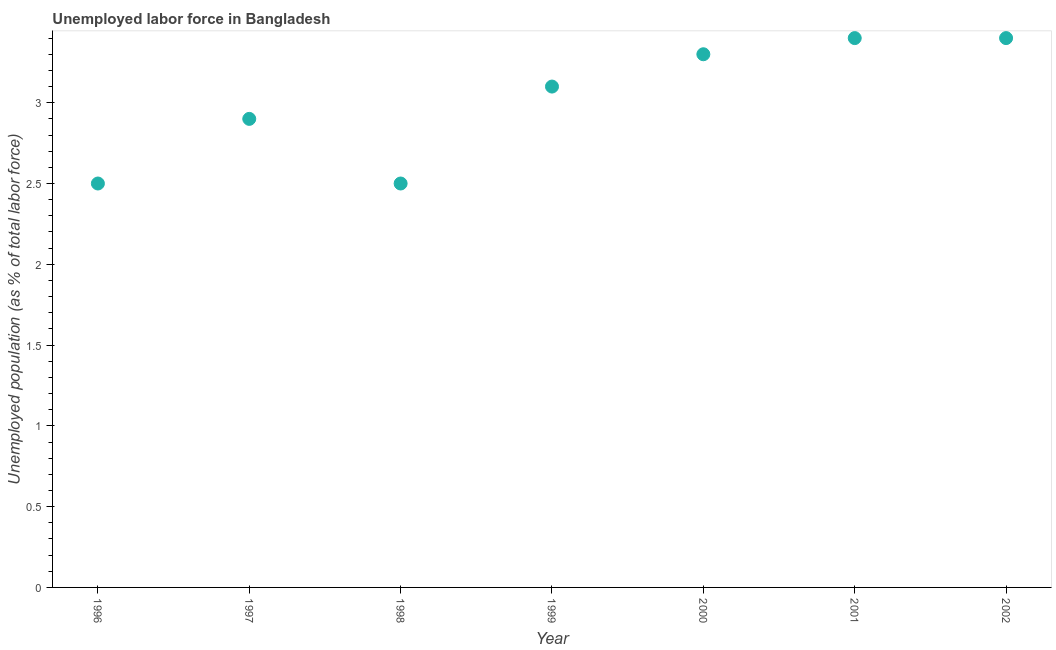What is the total unemployed population in 1999?
Make the answer very short. 3.1. Across all years, what is the maximum total unemployed population?
Your response must be concise. 3.4. Across all years, what is the minimum total unemployed population?
Your answer should be very brief. 2.5. What is the sum of the total unemployed population?
Provide a short and direct response. 21.1. What is the difference between the total unemployed population in 1997 and 2000?
Your answer should be very brief. -0.4. What is the average total unemployed population per year?
Keep it short and to the point. 3.01. What is the median total unemployed population?
Make the answer very short. 3.1. Do a majority of the years between 1996 and 2002 (inclusive) have total unemployed population greater than 3.2 %?
Offer a very short reply. No. What is the ratio of the total unemployed population in 1997 to that in 2000?
Offer a very short reply. 0.88. Is the total unemployed population in 2001 less than that in 2002?
Your answer should be very brief. No. What is the difference between the highest and the second highest total unemployed population?
Make the answer very short. 0. What is the difference between the highest and the lowest total unemployed population?
Make the answer very short. 0.9. In how many years, is the total unemployed population greater than the average total unemployed population taken over all years?
Provide a succinct answer. 4. Does the total unemployed population monotonically increase over the years?
Offer a very short reply. No. How many years are there in the graph?
Your response must be concise. 7. What is the difference between two consecutive major ticks on the Y-axis?
Keep it short and to the point. 0.5. Does the graph contain grids?
Offer a terse response. No. What is the title of the graph?
Make the answer very short. Unemployed labor force in Bangladesh. What is the label or title of the X-axis?
Your response must be concise. Year. What is the label or title of the Y-axis?
Make the answer very short. Unemployed population (as % of total labor force). What is the Unemployed population (as % of total labor force) in 1996?
Ensure brevity in your answer.  2.5. What is the Unemployed population (as % of total labor force) in 1997?
Give a very brief answer. 2.9. What is the Unemployed population (as % of total labor force) in 1999?
Your answer should be very brief. 3.1. What is the Unemployed population (as % of total labor force) in 2000?
Give a very brief answer. 3.3. What is the Unemployed population (as % of total labor force) in 2001?
Make the answer very short. 3.4. What is the Unemployed population (as % of total labor force) in 2002?
Offer a very short reply. 3.4. What is the difference between the Unemployed population (as % of total labor force) in 1997 and 1998?
Offer a terse response. 0.4. What is the difference between the Unemployed population (as % of total labor force) in 1997 and 1999?
Offer a very short reply. -0.2. What is the difference between the Unemployed population (as % of total labor force) in 1997 and 2001?
Give a very brief answer. -0.5. What is the difference between the Unemployed population (as % of total labor force) in 1998 and 1999?
Keep it short and to the point. -0.6. What is the difference between the Unemployed population (as % of total labor force) in 1998 and 2001?
Make the answer very short. -0.9. What is the difference between the Unemployed population (as % of total labor force) in 1999 and 2002?
Provide a succinct answer. -0.3. What is the difference between the Unemployed population (as % of total labor force) in 2000 and 2001?
Keep it short and to the point. -0.1. What is the difference between the Unemployed population (as % of total labor force) in 2000 and 2002?
Your answer should be very brief. -0.1. What is the ratio of the Unemployed population (as % of total labor force) in 1996 to that in 1997?
Ensure brevity in your answer.  0.86. What is the ratio of the Unemployed population (as % of total labor force) in 1996 to that in 1998?
Your answer should be compact. 1. What is the ratio of the Unemployed population (as % of total labor force) in 1996 to that in 1999?
Offer a terse response. 0.81. What is the ratio of the Unemployed population (as % of total labor force) in 1996 to that in 2000?
Give a very brief answer. 0.76. What is the ratio of the Unemployed population (as % of total labor force) in 1996 to that in 2001?
Give a very brief answer. 0.73. What is the ratio of the Unemployed population (as % of total labor force) in 1996 to that in 2002?
Offer a very short reply. 0.73. What is the ratio of the Unemployed population (as % of total labor force) in 1997 to that in 1998?
Provide a succinct answer. 1.16. What is the ratio of the Unemployed population (as % of total labor force) in 1997 to that in 1999?
Ensure brevity in your answer.  0.94. What is the ratio of the Unemployed population (as % of total labor force) in 1997 to that in 2000?
Offer a very short reply. 0.88. What is the ratio of the Unemployed population (as % of total labor force) in 1997 to that in 2001?
Your answer should be compact. 0.85. What is the ratio of the Unemployed population (as % of total labor force) in 1997 to that in 2002?
Your response must be concise. 0.85. What is the ratio of the Unemployed population (as % of total labor force) in 1998 to that in 1999?
Your answer should be compact. 0.81. What is the ratio of the Unemployed population (as % of total labor force) in 1998 to that in 2000?
Give a very brief answer. 0.76. What is the ratio of the Unemployed population (as % of total labor force) in 1998 to that in 2001?
Provide a succinct answer. 0.73. What is the ratio of the Unemployed population (as % of total labor force) in 1998 to that in 2002?
Your response must be concise. 0.73. What is the ratio of the Unemployed population (as % of total labor force) in 1999 to that in 2000?
Provide a short and direct response. 0.94. What is the ratio of the Unemployed population (as % of total labor force) in 1999 to that in 2001?
Keep it short and to the point. 0.91. What is the ratio of the Unemployed population (as % of total labor force) in 1999 to that in 2002?
Make the answer very short. 0.91. What is the ratio of the Unemployed population (as % of total labor force) in 2000 to that in 2001?
Ensure brevity in your answer.  0.97. What is the ratio of the Unemployed population (as % of total labor force) in 2000 to that in 2002?
Provide a succinct answer. 0.97. 